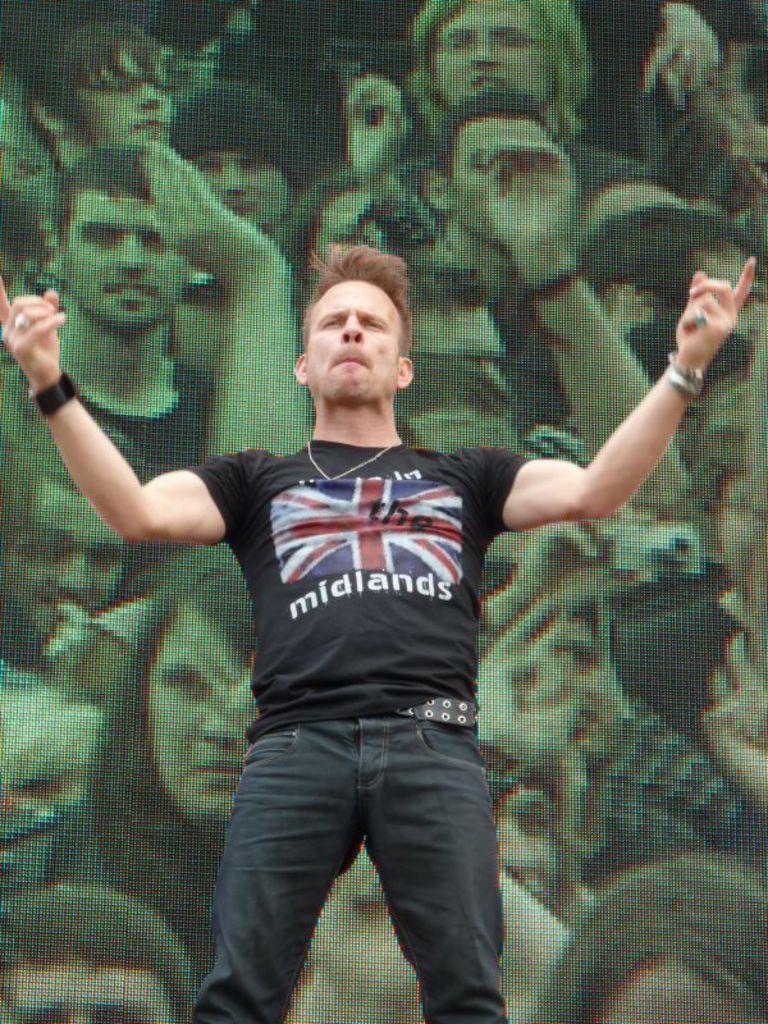Could you give a brief overview of what you see in this image? In this picture we can see a man standing in front of a display. 